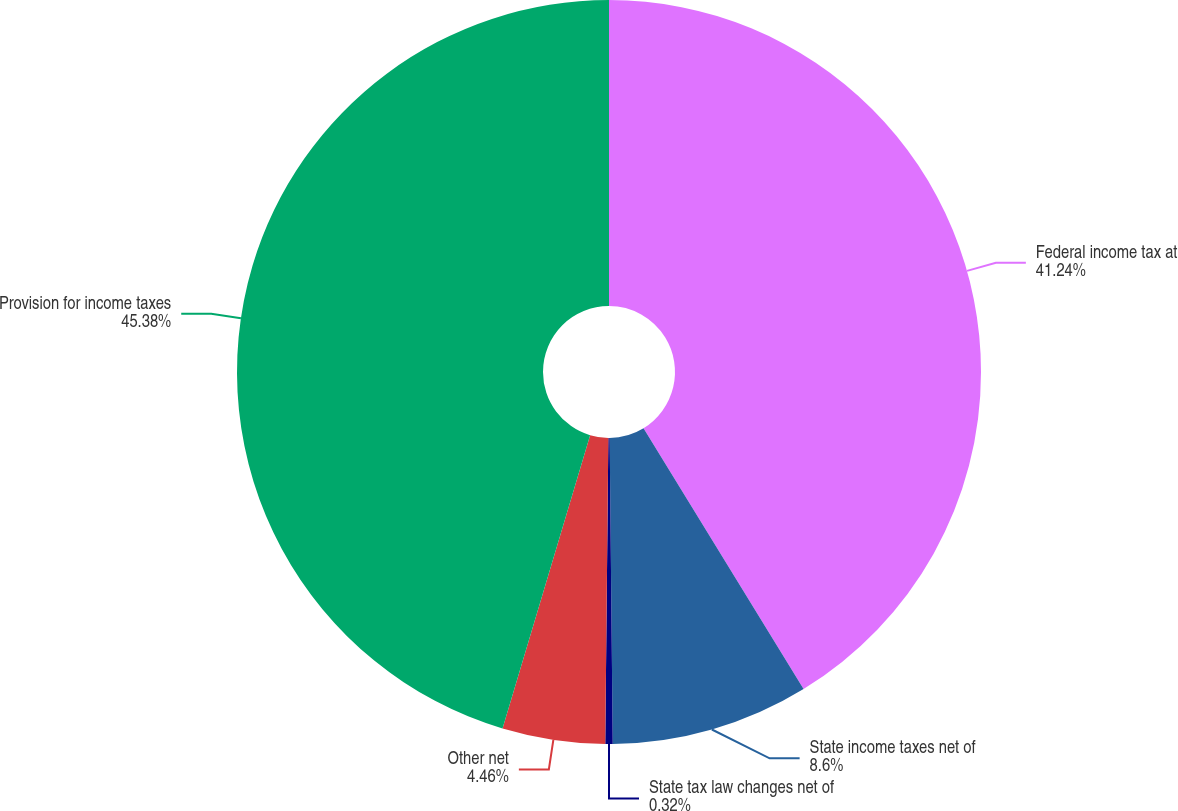<chart> <loc_0><loc_0><loc_500><loc_500><pie_chart><fcel>Federal income tax at<fcel>State income taxes net of<fcel>State tax law changes net of<fcel>Other net<fcel>Provision for income taxes<nl><fcel>41.24%<fcel>8.6%<fcel>0.32%<fcel>4.46%<fcel>45.38%<nl></chart> 